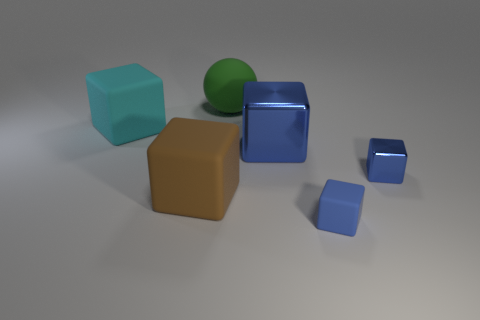Does the tiny matte cube have the same color as the tiny shiny block?
Offer a terse response. Yes. Is the big cube that is to the right of the green matte object made of the same material as the large cyan block?
Ensure brevity in your answer.  No. How many cubes are in front of the big blue object and right of the ball?
Keep it short and to the point. 2. What is the size of the block that is behind the blue metal thing behind the small blue shiny thing?
Provide a short and direct response. Large. Are there more green rubber things than big matte objects?
Provide a short and direct response. No. Does the large object to the right of the big green ball have the same color as the small thing that is in front of the tiny blue metal thing?
Give a very brief answer. Yes. Are there any tiny blocks to the left of the matte thing that is to the right of the big matte ball?
Offer a terse response. No. Is the number of shiny things in front of the big brown block less than the number of cyan cubes that are on the left side of the big cyan block?
Keep it short and to the point. No. Is the material of the big thing right of the ball the same as the tiny blue object behind the small blue rubber thing?
Provide a short and direct response. Yes. How many big objects are either cyan metallic balls or blue things?
Make the answer very short. 1. 